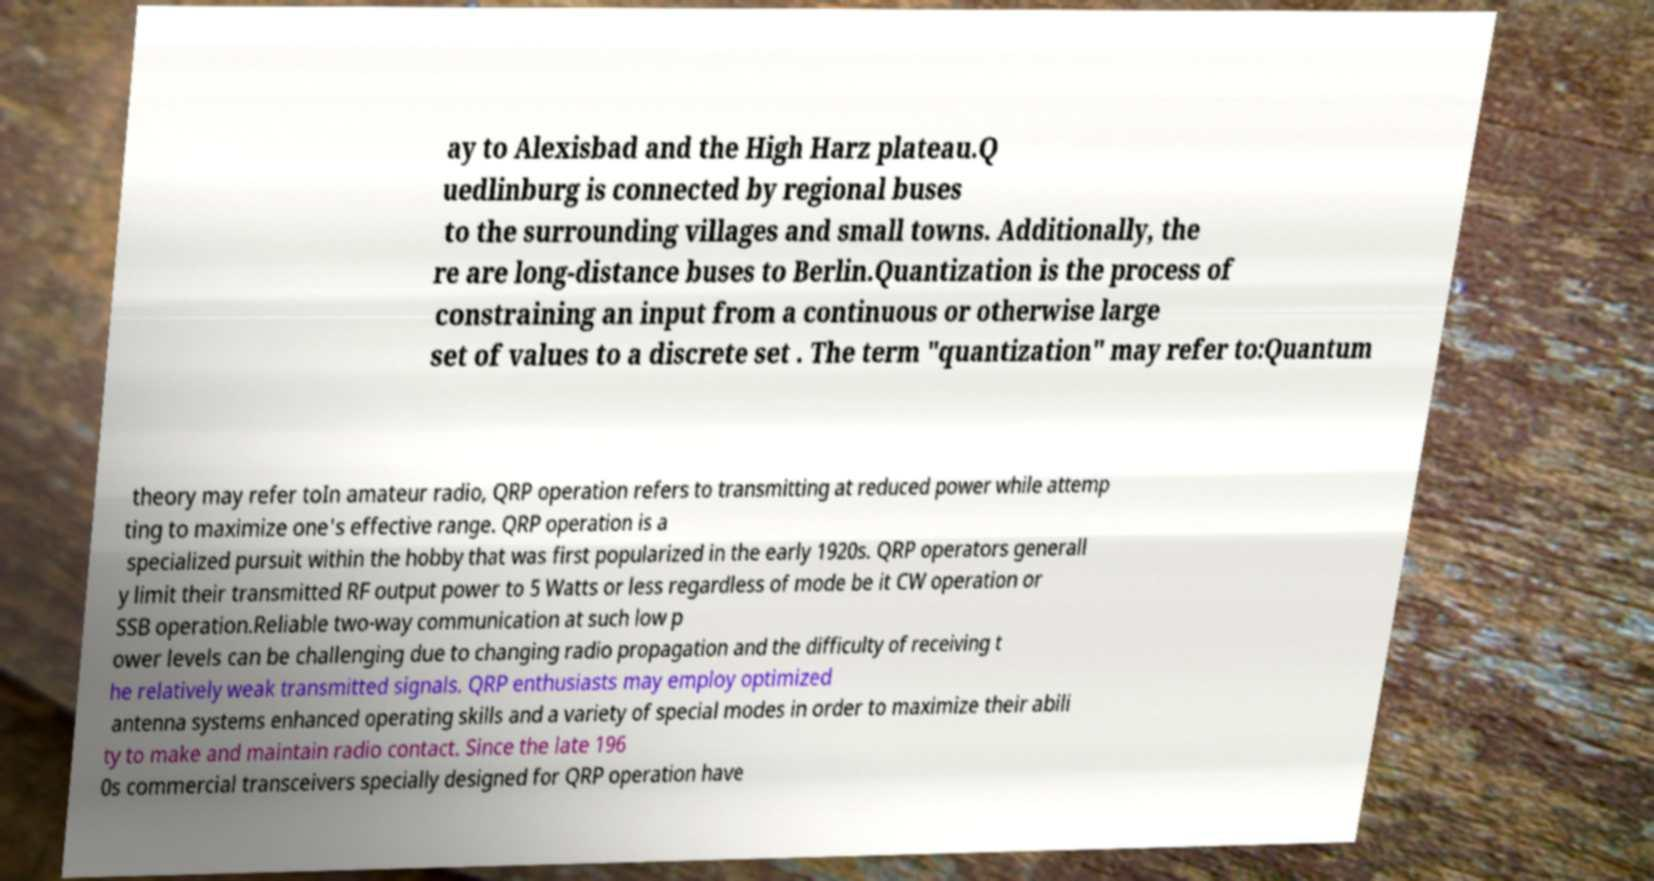For documentation purposes, I need the text within this image transcribed. Could you provide that? ay to Alexisbad and the High Harz plateau.Q uedlinburg is connected by regional buses to the surrounding villages and small towns. Additionally, the re are long-distance buses to Berlin.Quantization is the process of constraining an input from a continuous or otherwise large set of values to a discrete set . The term "quantization" may refer to:Quantum theory may refer toIn amateur radio, QRP operation refers to transmitting at reduced power while attemp ting to maximize one's effective range. QRP operation is a specialized pursuit within the hobby that was first popularized in the early 1920s. QRP operators generall y limit their transmitted RF output power to 5 Watts or less regardless of mode be it CW operation or SSB operation.Reliable two-way communication at such low p ower levels can be challenging due to changing radio propagation and the difficulty of receiving t he relatively weak transmitted signals. QRP enthusiasts may employ optimized antenna systems enhanced operating skills and a variety of special modes in order to maximize their abili ty to make and maintain radio contact. Since the late 196 0s commercial transceivers specially designed for QRP operation have 